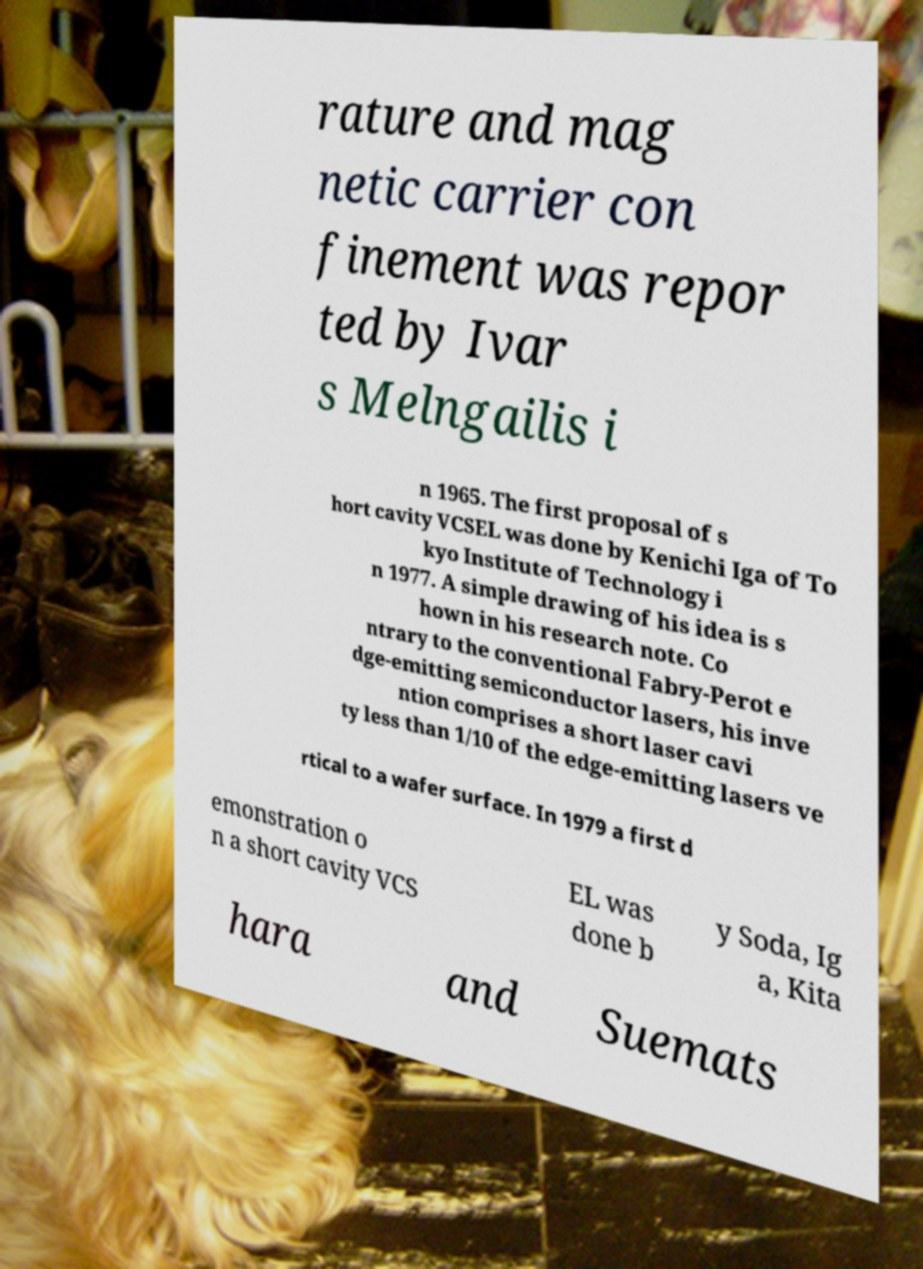I need the written content from this picture converted into text. Can you do that? rature and mag netic carrier con finement was repor ted by Ivar s Melngailis i n 1965. The first proposal of s hort cavity VCSEL was done by Kenichi Iga of To kyo Institute of Technology i n 1977. A simple drawing of his idea is s hown in his research note. Co ntrary to the conventional Fabry-Perot e dge-emitting semiconductor lasers, his inve ntion comprises a short laser cavi ty less than 1/10 of the edge-emitting lasers ve rtical to a wafer surface. In 1979 a first d emonstration o n a short cavity VCS EL was done b y Soda, Ig a, Kita hara and Suemats 